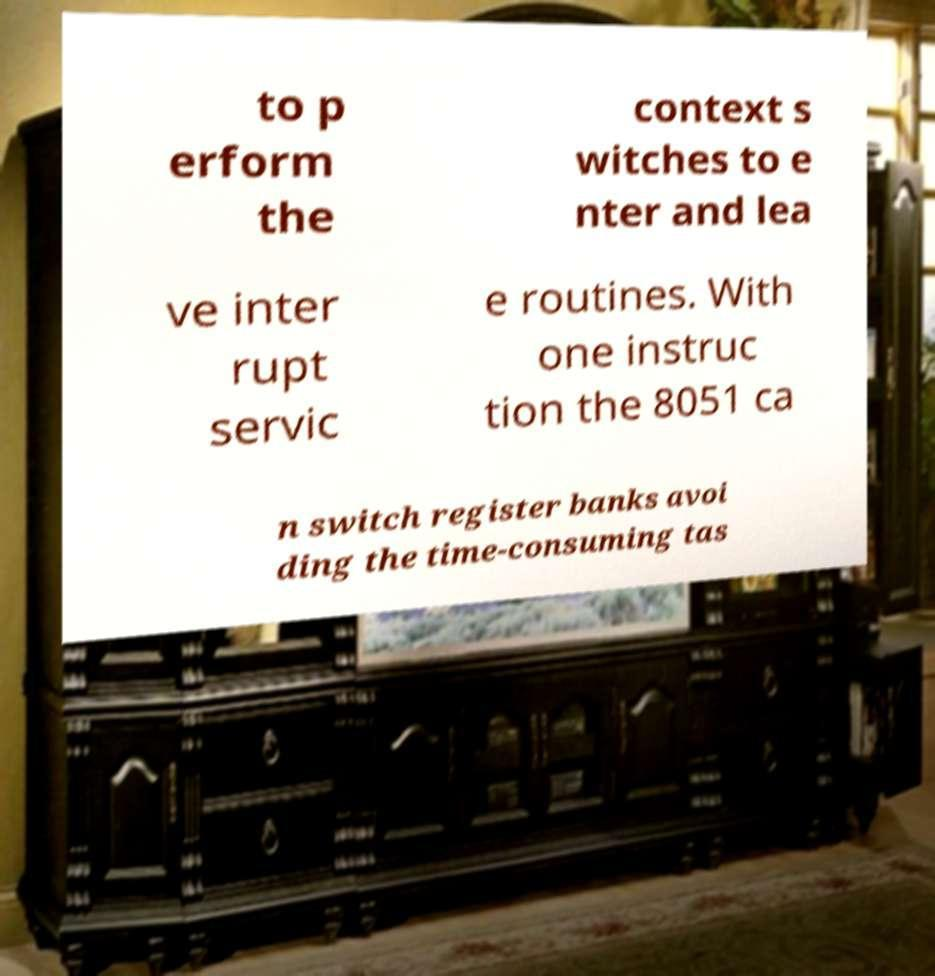Can you read and provide the text displayed in the image?This photo seems to have some interesting text. Can you extract and type it out for me? to p erform the context s witches to e nter and lea ve inter rupt servic e routines. With one instruc tion the 8051 ca n switch register banks avoi ding the time-consuming tas 